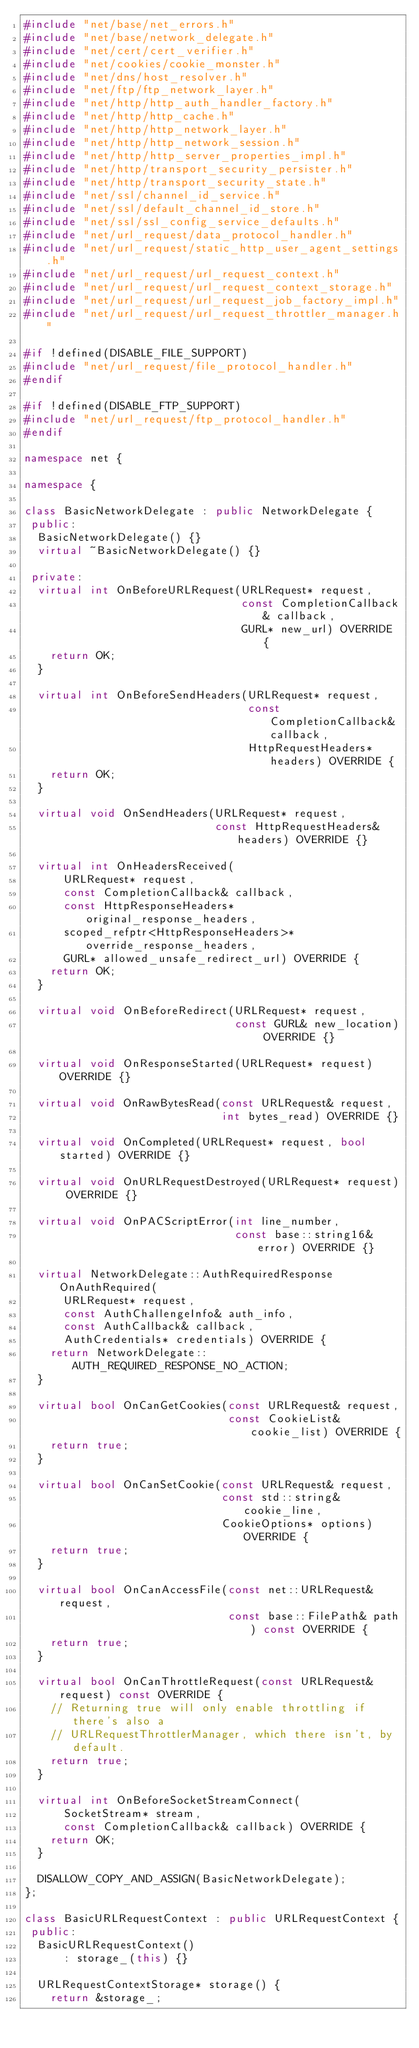<code> <loc_0><loc_0><loc_500><loc_500><_C++_>#include "net/base/net_errors.h"
#include "net/base/network_delegate.h"
#include "net/cert/cert_verifier.h"
#include "net/cookies/cookie_monster.h"
#include "net/dns/host_resolver.h"
#include "net/ftp/ftp_network_layer.h"
#include "net/http/http_auth_handler_factory.h"
#include "net/http/http_cache.h"
#include "net/http/http_network_layer.h"
#include "net/http/http_network_session.h"
#include "net/http/http_server_properties_impl.h"
#include "net/http/transport_security_persister.h"
#include "net/http/transport_security_state.h"
#include "net/ssl/channel_id_service.h"
#include "net/ssl/default_channel_id_store.h"
#include "net/ssl/ssl_config_service_defaults.h"
#include "net/url_request/data_protocol_handler.h"
#include "net/url_request/static_http_user_agent_settings.h"
#include "net/url_request/url_request_context.h"
#include "net/url_request/url_request_context_storage.h"
#include "net/url_request/url_request_job_factory_impl.h"
#include "net/url_request/url_request_throttler_manager.h"

#if !defined(DISABLE_FILE_SUPPORT)
#include "net/url_request/file_protocol_handler.h"
#endif

#if !defined(DISABLE_FTP_SUPPORT)
#include "net/url_request/ftp_protocol_handler.h"
#endif

namespace net {

namespace {

class BasicNetworkDelegate : public NetworkDelegate {
 public:
  BasicNetworkDelegate() {}
  virtual ~BasicNetworkDelegate() {}

 private:
  virtual int OnBeforeURLRequest(URLRequest* request,
                                 const CompletionCallback& callback,
                                 GURL* new_url) OVERRIDE {
    return OK;
  }

  virtual int OnBeforeSendHeaders(URLRequest* request,
                                  const CompletionCallback& callback,
                                  HttpRequestHeaders* headers) OVERRIDE {
    return OK;
  }

  virtual void OnSendHeaders(URLRequest* request,
                             const HttpRequestHeaders& headers) OVERRIDE {}

  virtual int OnHeadersReceived(
      URLRequest* request,
      const CompletionCallback& callback,
      const HttpResponseHeaders* original_response_headers,
      scoped_refptr<HttpResponseHeaders>* override_response_headers,
      GURL* allowed_unsafe_redirect_url) OVERRIDE {
    return OK;
  }

  virtual void OnBeforeRedirect(URLRequest* request,
                                const GURL& new_location) OVERRIDE {}

  virtual void OnResponseStarted(URLRequest* request) OVERRIDE {}

  virtual void OnRawBytesRead(const URLRequest& request,
                              int bytes_read) OVERRIDE {}

  virtual void OnCompleted(URLRequest* request, bool started) OVERRIDE {}

  virtual void OnURLRequestDestroyed(URLRequest* request) OVERRIDE {}

  virtual void OnPACScriptError(int line_number,
                                const base::string16& error) OVERRIDE {}

  virtual NetworkDelegate::AuthRequiredResponse OnAuthRequired(
      URLRequest* request,
      const AuthChallengeInfo& auth_info,
      const AuthCallback& callback,
      AuthCredentials* credentials) OVERRIDE {
    return NetworkDelegate::AUTH_REQUIRED_RESPONSE_NO_ACTION;
  }

  virtual bool OnCanGetCookies(const URLRequest& request,
                               const CookieList& cookie_list) OVERRIDE {
    return true;
  }

  virtual bool OnCanSetCookie(const URLRequest& request,
                              const std::string& cookie_line,
                              CookieOptions* options) OVERRIDE {
    return true;
  }

  virtual bool OnCanAccessFile(const net::URLRequest& request,
                               const base::FilePath& path) const OVERRIDE {
    return true;
  }

  virtual bool OnCanThrottleRequest(const URLRequest& request) const OVERRIDE {
    // Returning true will only enable throttling if there's also a
    // URLRequestThrottlerManager, which there isn't, by default.
    return true;
  }

  virtual int OnBeforeSocketStreamConnect(
      SocketStream* stream,
      const CompletionCallback& callback) OVERRIDE {
    return OK;
  }

  DISALLOW_COPY_AND_ASSIGN(BasicNetworkDelegate);
};

class BasicURLRequestContext : public URLRequestContext {
 public:
  BasicURLRequestContext()
      : storage_(this) {}

  URLRequestContextStorage* storage() {
    return &storage_;</code> 